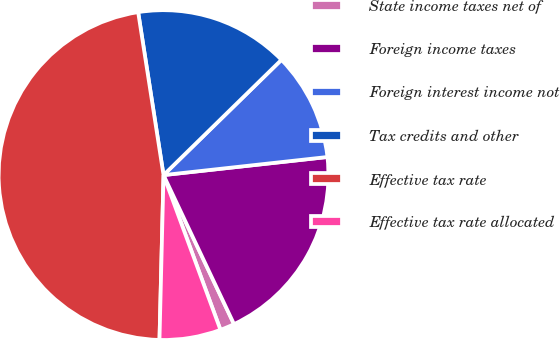<chart> <loc_0><loc_0><loc_500><loc_500><pie_chart><fcel>State income taxes net of<fcel>Foreign income taxes<fcel>Foreign interest income not<fcel>Tax credits and other<fcel>Effective tax rate<fcel>Effective tax rate allocated<nl><fcel>1.42%<fcel>19.72%<fcel>10.57%<fcel>15.14%<fcel>47.15%<fcel>6.0%<nl></chart> 